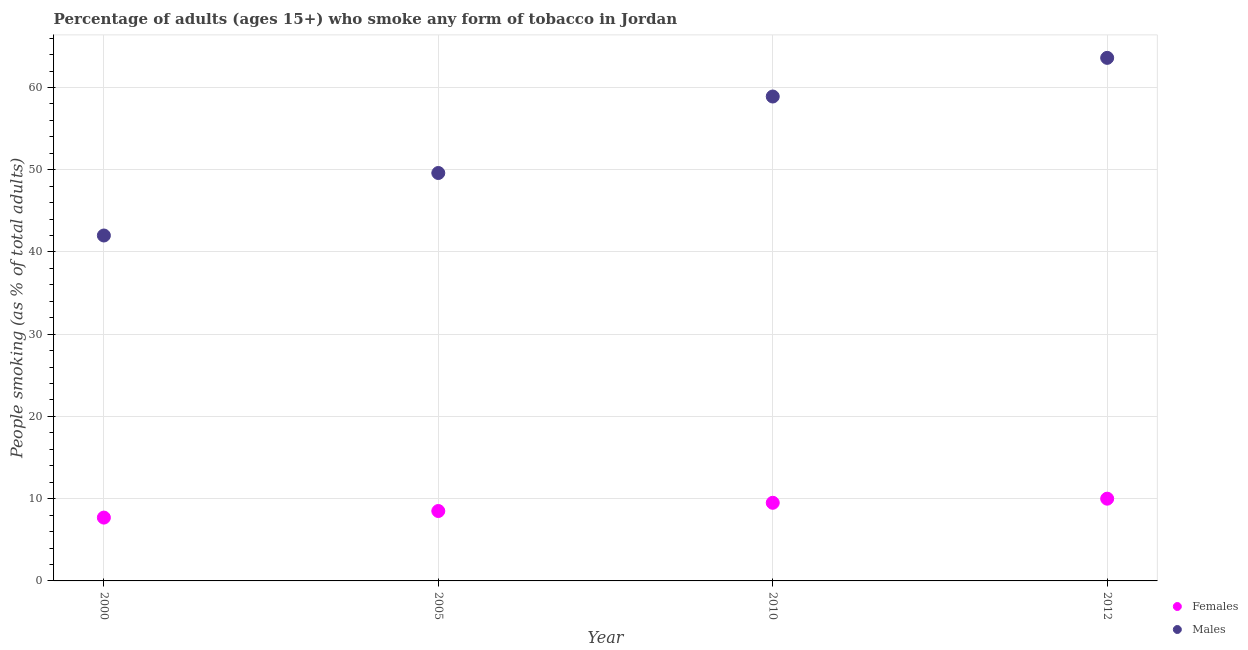How many different coloured dotlines are there?
Your response must be concise. 2. Is the number of dotlines equal to the number of legend labels?
Your answer should be compact. Yes. What is the percentage of males who smoke in 2012?
Offer a terse response. 63.6. Across all years, what is the maximum percentage of males who smoke?
Ensure brevity in your answer.  63.6. What is the total percentage of females who smoke in the graph?
Provide a succinct answer. 35.7. What is the difference between the percentage of females who smoke in 2000 and that in 2005?
Keep it short and to the point. -0.8. What is the difference between the percentage of females who smoke in 2012 and the percentage of males who smoke in 2005?
Provide a short and direct response. -39.6. What is the average percentage of females who smoke per year?
Your answer should be very brief. 8.93. In the year 2005, what is the difference between the percentage of females who smoke and percentage of males who smoke?
Your answer should be very brief. -41.1. In how many years, is the percentage of females who smoke greater than 46 %?
Your response must be concise. 0. Is the percentage of females who smoke in 2005 less than that in 2012?
Offer a terse response. Yes. Is the difference between the percentage of females who smoke in 2010 and 2012 greater than the difference between the percentage of males who smoke in 2010 and 2012?
Provide a short and direct response. Yes. What is the difference between the highest and the second highest percentage of females who smoke?
Your response must be concise. 0.5. What is the difference between the highest and the lowest percentage of females who smoke?
Keep it short and to the point. 2.3. What is the difference between two consecutive major ticks on the Y-axis?
Provide a succinct answer. 10. How many legend labels are there?
Offer a terse response. 2. What is the title of the graph?
Ensure brevity in your answer.  Percentage of adults (ages 15+) who smoke any form of tobacco in Jordan. What is the label or title of the X-axis?
Provide a succinct answer. Year. What is the label or title of the Y-axis?
Your answer should be compact. People smoking (as % of total adults). What is the People smoking (as % of total adults) of Males in 2000?
Your answer should be very brief. 42. What is the People smoking (as % of total adults) in Females in 2005?
Offer a terse response. 8.5. What is the People smoking (as % of total adults) of Males in 2005?
Give a very brief answer. 49.6. What is the People smoking (as % of total adults) of Males in 2010?
Provide a short and direct response. 58.9. What is the People smoking (as % of total adults) of Females in 2012?
Your response must be concise. 10. What is the People smoking (as % of total adults) of Males in 2012?
Your answer should be very brief. 63.6. Across all years, what is the maximum People smoking (as % of total adults) of Males?
Make the answer very short. 63.6. What is the total People smoking (as % of total adults) of Females in the graph?
Keep it short and to the point. 35.7. What is the total People smoking (as % of total adults) in Males in the graph?
Your answer should be very brief. 214.1. What is the difference between the People smoking (as % of total adults) of Females in 2000 and that in 2005?
Your answer should be very brief. -0.8. What is the difference between the People smoking (as % of total adults) in Females in 2000 and that in 2010?
Ensure brevity in your answer.  -1.8. What is the difference between the People smoking (as % of total adults) in Males in 2000 and that in 2010?
Offer a terse response. -16.9. What is the difference between the People smoking (as % of total adults) in Females in 2000 and that in 2012?
Your answer should be compact. -2.3. What is the difference between the People smoking (as % of total adults) in Males in 2000 and that in 2012?
Provide a short and direct response. -21.6. What is the difference between the People smoking (as % of total adults) in Males in 2005 and that in 2010?
Your answer should be compact. -9.3. What is the difference between the People smoking (as % of total adults) in Females in 2005 and that in 2012?
Keep it short and to the point. -1.5. What is the difference between the People smoking (as % of total adults) of Males in 2005 and that in 2012?
Your answer should be compact. -14. What is the difference between the People smoking (as % of total adults) in Females in 2000 and the People smoking (as % of total adults) in Males in 2005?
Ensure brevity in your answer.  -41.9. What is the difference between the People smoking (as % of total adults) in Females in 2000 and the People smoking (as % of total adults) in Males in 2010?
Provide a succinct answer. -51.2. What is the difference between the People smoking (as % of total adults) of Females in 2000 and the People smoking (as % of total adults) of Males in 2012?
Make the answer very short. -55.9. What is the difference between the People smoking (as % of total adults) in Females in 2005 and the People smoking (as % of total adults) in Males in 2010?
Give a very brief answer. -50.4. What is the difference between the People smoking (as % of total adults) of Females in 2005 and the People smoking (as % of total adults) of Males in 2012?
Your answer should be compact. -55.1. What is the difference between the People smoking (as % of total adults) of Females in 2010 and the People smoking (as % of total adults) of Males in 2012?
Make the answer very short. -54.1. What is the average People smoking (as % of total adults) in Females per year?
Keep it short and to the point. 8.93. What is the average People smoking (as % of total adults) in Males per year?
Your response must be concise. 53.52. In the year 2000, what is the difference between the People smoking (as % of total adults) of Females and People smoking (as % of total adults) of Males?
Offer a very short reply. -34.3. In the year 2005, what is the difference between the People smoking (as % of total adults) of Females and People smoking (as % of total adults) of Males?
Give a very brief answer. -41.1. In the year 2010, what is the difference between the People smoking (as % of total adults) in Females and People smoking (as % of total adults) in Males?
Ensure brevity in your answer.  -49.4. In the year 2012, what is the difference between the People smoking (as % of total adults) in Females and People smoking (as % of total adults) in Males?
Keep it short and to the point. -53.6. What is the ratio of the People smoking (as % of total adults) of Females in 2000 to that in 2005?
Your response must be concise. 0.91. What is the ratio of the People smoking (as % of total adults) of Males in 2000 to that in 2005?
Offer a terse response. 0.85. What is the ratio of the People smoking (as % of total adults) in Females in 2000 to that in 2010?
Keep it short and to the point. 0.81. What is the ratio of the People smoking (as % of total adults) in Males in 2000 to that in 2010?
Offer a very short reply. 0.71. What is the ratio of the People smoking (as % of total adults) in Females in 2000 to that in 2012?
Offer a very short reply. 0.77. What is the ratio of the People smoking (as % of total adults) of Males in 2000 to that in 2012?
Offer a very short reply. 0.66. What is the ratio of the People smoking (as % of total adults) in Females in 2005 to that in 2010?
Provide a short and direct response. 0.89. What is the ratio of the People smoking (as % of total adults) of Males in 2005 to that in 2010?
Offer a terse response. 0.84. What is the ratio of the People smoking (as % of total adults) in Males in 2005 to that in 2012?
Offer a terse response. 0.78. What is the ratio of the People smoking (as % of total adults) of Females in 2010 to that in 2012?
Your answer should be compact. 0.95. What is the ratio of the People smoking (as % of total adults) of Males in 2010 to that in 2012?
Your answer should be compact. 0.93. What is the difference between the highest and the lowest People smoking (as % of total adults) in Males?
Keep it short and to the point. 21.6. 